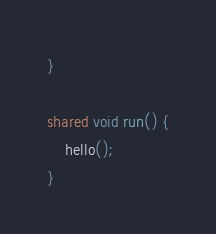<code> <loc_0><loc_0><loc_500><loc_500><_Ceylon_>}

shared void run() {
    hello();
}
</code> 